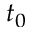Convert formula to latex. <formula><loc_0><loc_0><loc_500><loc_500>t _ { 0 }</formula> 